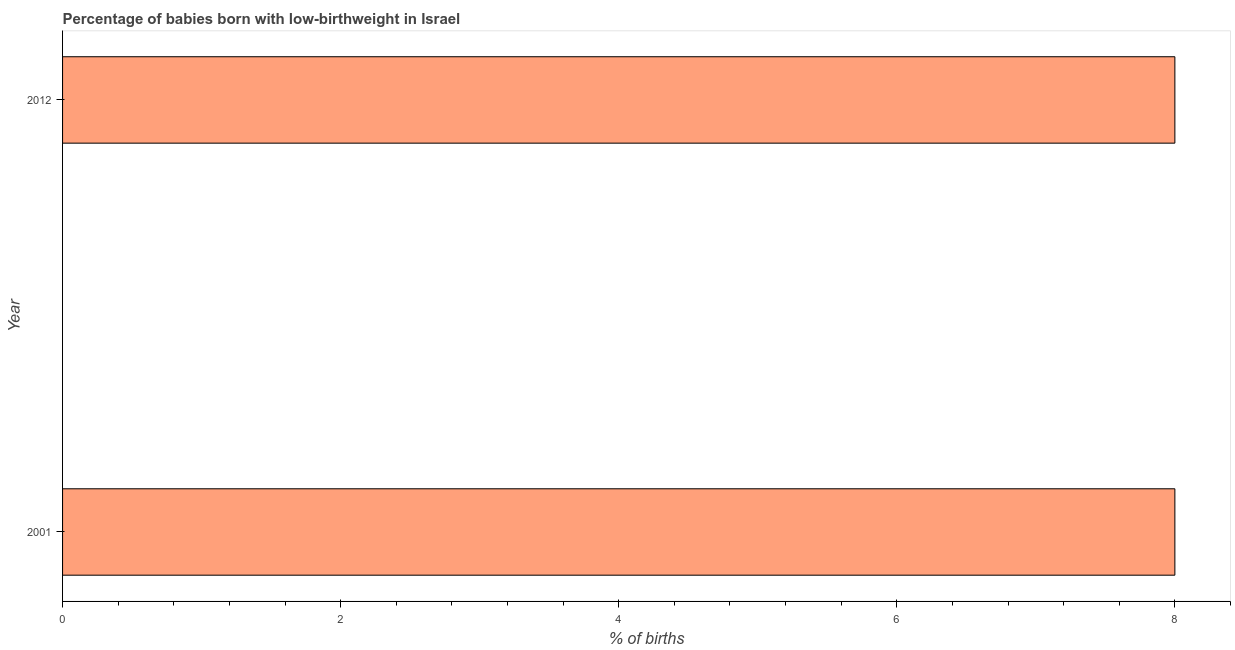Does the graph contain any zero values?
Provide a succinct answer. No. Does the graph contain grids?
Make the answer very short. No. What is the title of the graph?
Provide a short and direct response. Percentage of babies born with low-birthweight in Israel. What is the label or title of the X-axis?
Your response must be concise. % of births. What is the percentage of babies who were born with low-birthweight in 2012?
Make the answer very short. 8. Across all years, what is the maximum percentage of babies who were born with low-birthweight?
Your answer should be compact. 8. What is the difference between the percentage of babies who were born with low-birthweight in 2001 and 2012?
Keep it short and to the point. 0. What is the average percentage of babies who were born with low-birthweight per year?
Offer a terse response. 8. What is the median percentage of babies who were born with low-birthweight?
Offer a very short reply. 8. Do a majority of the years between 2001 and 2012 (inclusive) have percentage of babies who were born with low-birthweight greater than 5.6 %?
Keep it short and to the point. Yes. What is the ratio of the percentage of babies who were born with low-birthweight in 2001 to that in 2012?
Offer a terse response. 1. How many bars are there?
Ensure brevity in your answer.  2. What is the difference between two consecutive major ticks on the X-axis?
Keep it short and to the point. 2. Are the values on the major ticks of X-axis written in scientific E-notation?
Your answer should be very brief. No. What is the difference between the % of births in 2001 and 2012?
Provide a succinct answer. 0. 